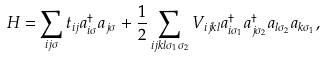<formula> <loc_0><loc_0><loc_500><loc_500>H = \sum _ { i j \sigma } t _ { i j } a ^ { \dagger } _ { i \sigma } a _ { j \sigma } + \frac { 1 } { 2 } \sum _ { i j k l \sigma _ { 1 } \sigma _ { 2 } } V _ { i j k l } a ^ { \dagger } _ { i \sigma _ { 1 } } a ^ { \dagger } _ { j \sigma _ { 2 } } a _ { l \sigma _ { 2 } } a _ { k \sigma _ { 1 } } ,</formula> 